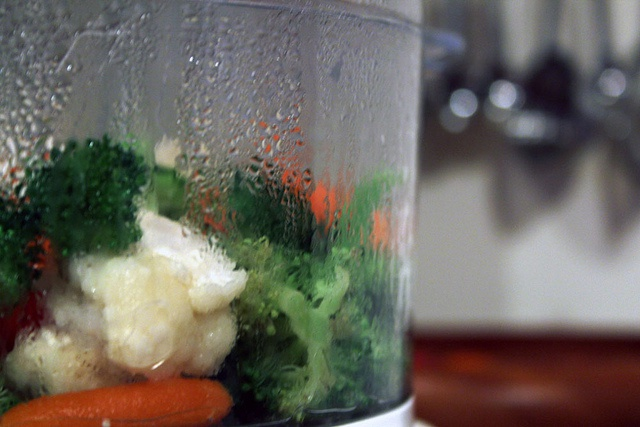Describe the objects in this image and their specific colors. I can see broccoli in purple, darkgreen, black, and green tones, broccoli in purple, black, darkgreen, and green tones, broccoli in purple, black, and darkgreen tones, carrot in purple, brown, maroon, and black tones, and carrot in purple, black, maroon, and brown tones in this image. 